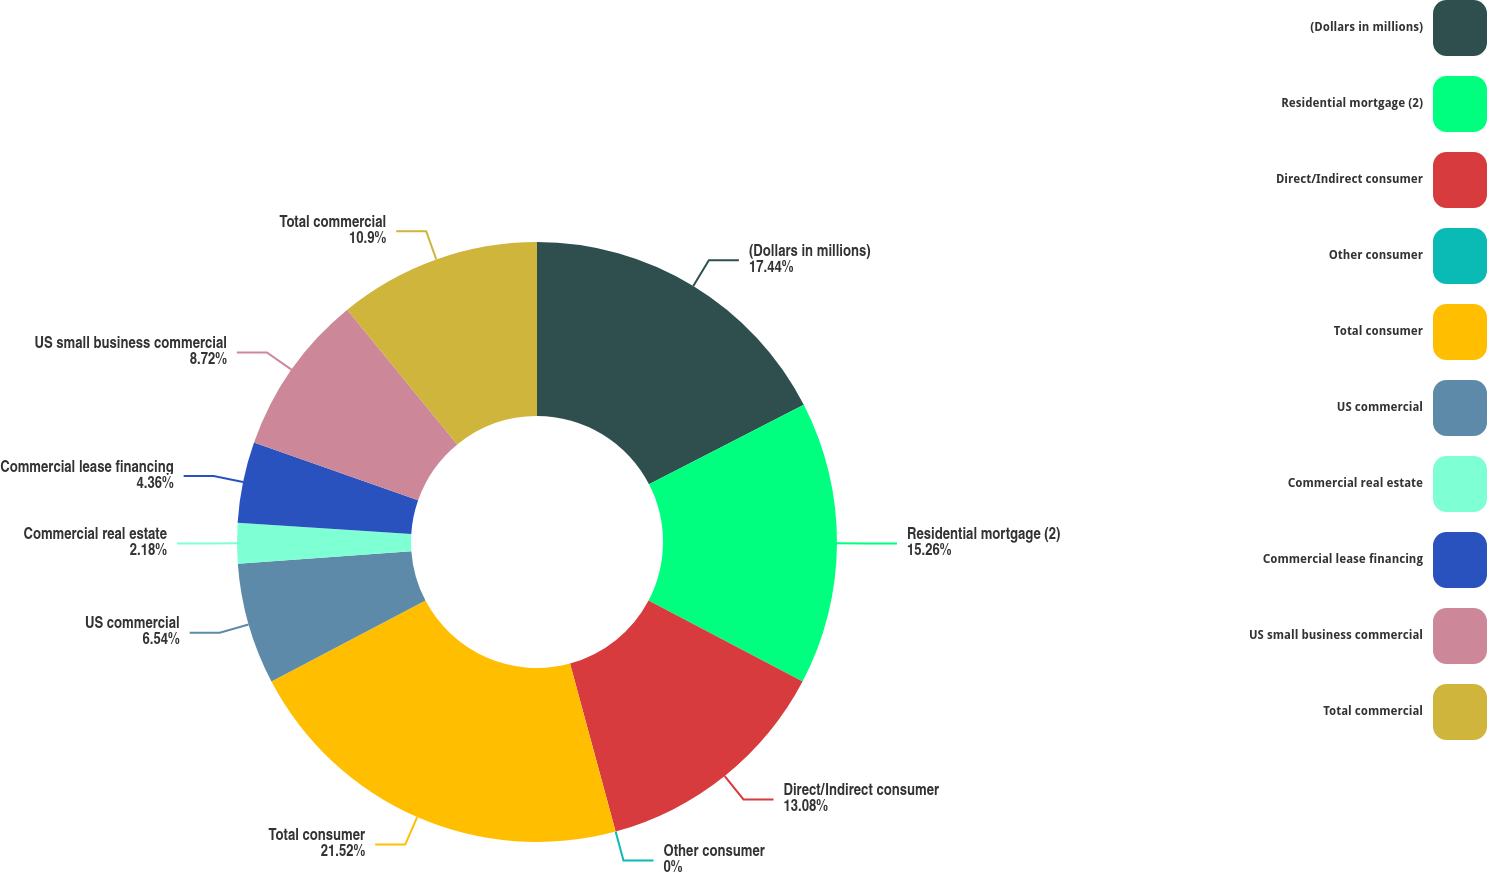<chart> <loc_0><loc_0><loc_500><loc_500><pie_chart><fcel>(Dollars in millions)<fcel>Residential mortgage (2)<fcel>Direct/Indirect consumer<fcel>Other consumer<fcel>Total consumer<fcel>US commercial<fcel>Commercial real estate<fcel>Commercial lease financing<fcel>US small business commercial<fcel>Total commercial<nl><fcel>17.44%<fcel>15.26%<fcel>13.08%<fcel>0.0%<fcel>21.52%<fcel>6.54%<fcel>2.18%<fcel>4.36%<fcel>8.72%<fcel>10.9%<nl></chart> 